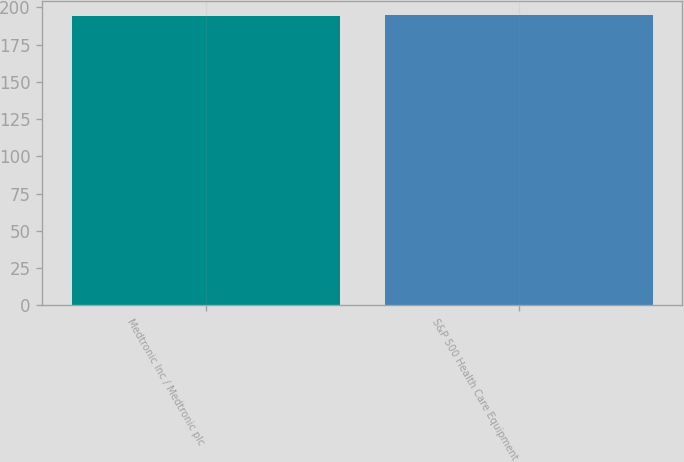<chart> <loc_0><loc_0><loc_500><loc_500><bar_chart><fcel>Medtronic Inc / Medtronic plc<fcel>S&P 500 Health Care Equipment<nl><fcel>194.03<fcel>194.71<nl></chart> 